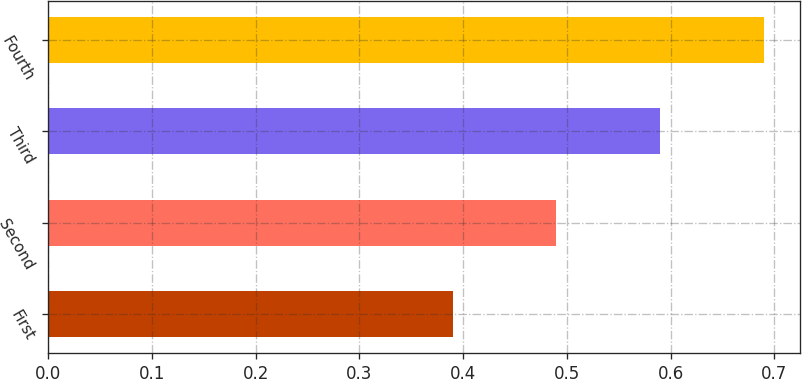<chart> <loc_0><loc_0><loc_500><loc_500><bar_chart><fcel>First<fcel>Second<fcel>Third<fcel>Fourth<nl><fcel>0.39<fcel>0.49<fcel>0.59<fcel>0.69<nl></chart> 